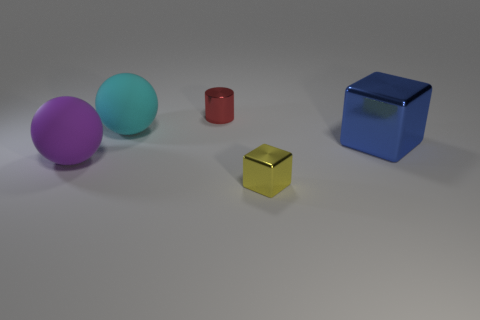What is the material of the thing that is both behind the blue shiny cube and in front of the red cylinder?
Offer a terse response. Rubber. Are there any other purple rubber things that have the same shape as the purple thing?
Give a very brief answer. No. There is a small object that is right of the small red metal cylinder; is its shape the same as the big blue shiny thing?
Make the answer very short. Yes. How many things are on the right side of the cyan matte sphere and in front of the large blue thing?
Provide a succinct answer. 1. What is the shape of the tiny object that is in front of the large purple rubber ball?
Your response must be concise. Cube. How many large blue cubes have the same material as the red cylinder?
Offer a terse response. 1. Do the blue thing and the tiny metal object that is behind the tiny yellow metallic cube have the same shape?
Offer a very short reply. No. Is there a big metal thing behind the metallic object behind the large thing behind the big metallic cube?
Give a very brief answer. No. What size is the rubber thing behind the big purple sphere?
Keep it short and to the point. Large. There is a yellow object that is the same size as the red metallic object; what is its material?
Offer a very short reply. Metal. 